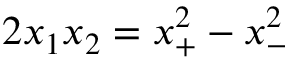Convert formula to latex. <formula><loc_0><loc_0><loc_500><loc_500>2 x _ { 1 } x _ { 2 } = x _ { + } ^ { 2 } - x _ { - } ^ { 2 }</formula> 